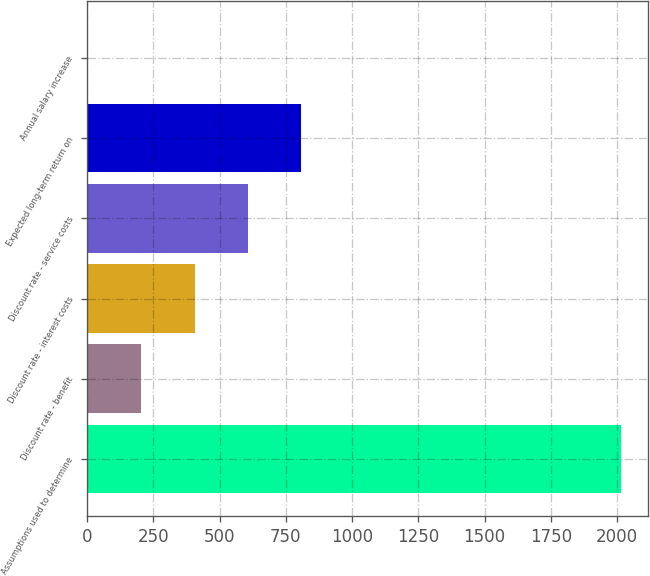Convert chart. <chart><loc_0><loc_0><loc_500><loc_500><bar_chart><fcel>Assumptions used to determine<fcel>Discount rate - benefit<fcel>Discount rate - interest costs<fcel>Discount rate - service costs<fcel>Expected long-term return on<fcel>Annual salary increase<nl><fcel>2015<fcel>204.73<fcel>405.87<fcel>607.01<fcel>808.15<fcel>3.59<nl></chart> 